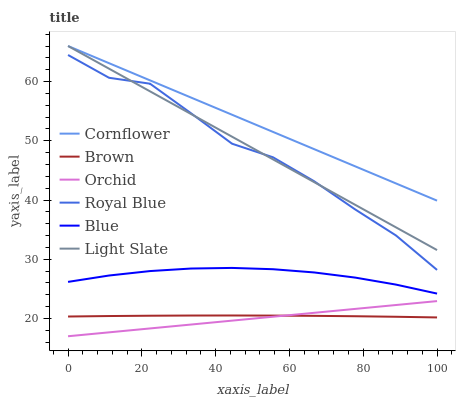Does Brown have the minimum area under the curve?
Answer yes or no. No. Does Brown have the maximum area under the curve?
Answer yes or no. No. Is Cornflower the smoothest?
Answer yes or no. No. Is Cornflower the roughest?
Answer yes or no. No. Does Brown have the lowest value?
Answer yes or no. No. Does Brown have the highest value?
Answer yes or no. No. Is Royal Blue less than Cornflower?
Answer yes or no. Yes. Is Light Slate greater than Blue?
Answer yes or no. Yes. Does Royal Blue intersect Cornflower?
Answer yes or no. No. 